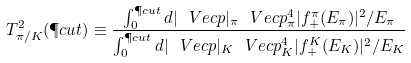<formula> <loc_0><loc_0><loc_500><loc_500>T _ { \pi / K } ^ { 2 } ( \P c u t ) \equiv \frac { \int _ { 0 } ^ { \P c u t } d | \ V e c { p } | _ { \pi } \ V e c { p } _ { \pi } ^ { 4 } | f ^ { \pi } _ { + } ( E _ { \pi } ) | ^ { 2 } / E _ { \pi } } { \int _ { 0 } ^ { \P c u t } d | \ V e c { p } | _ { K } \ V e c { p } _ { K } ^ { 4 } | f ^ { K } _ { + } ( E _ { K } ) | ^ { 2 } / E _ { K } }</formula> 